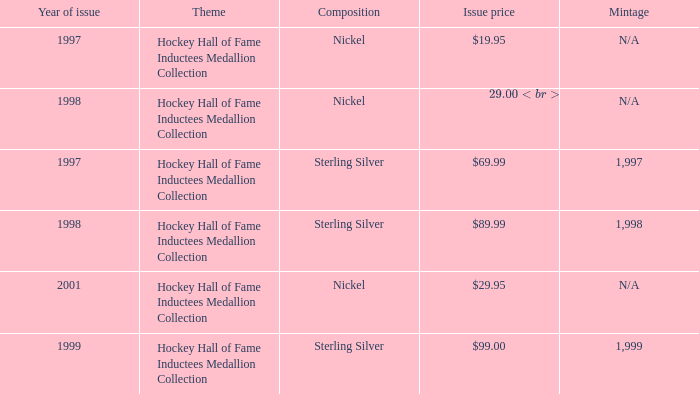How many years was the issue price $19.95? 1.0. 